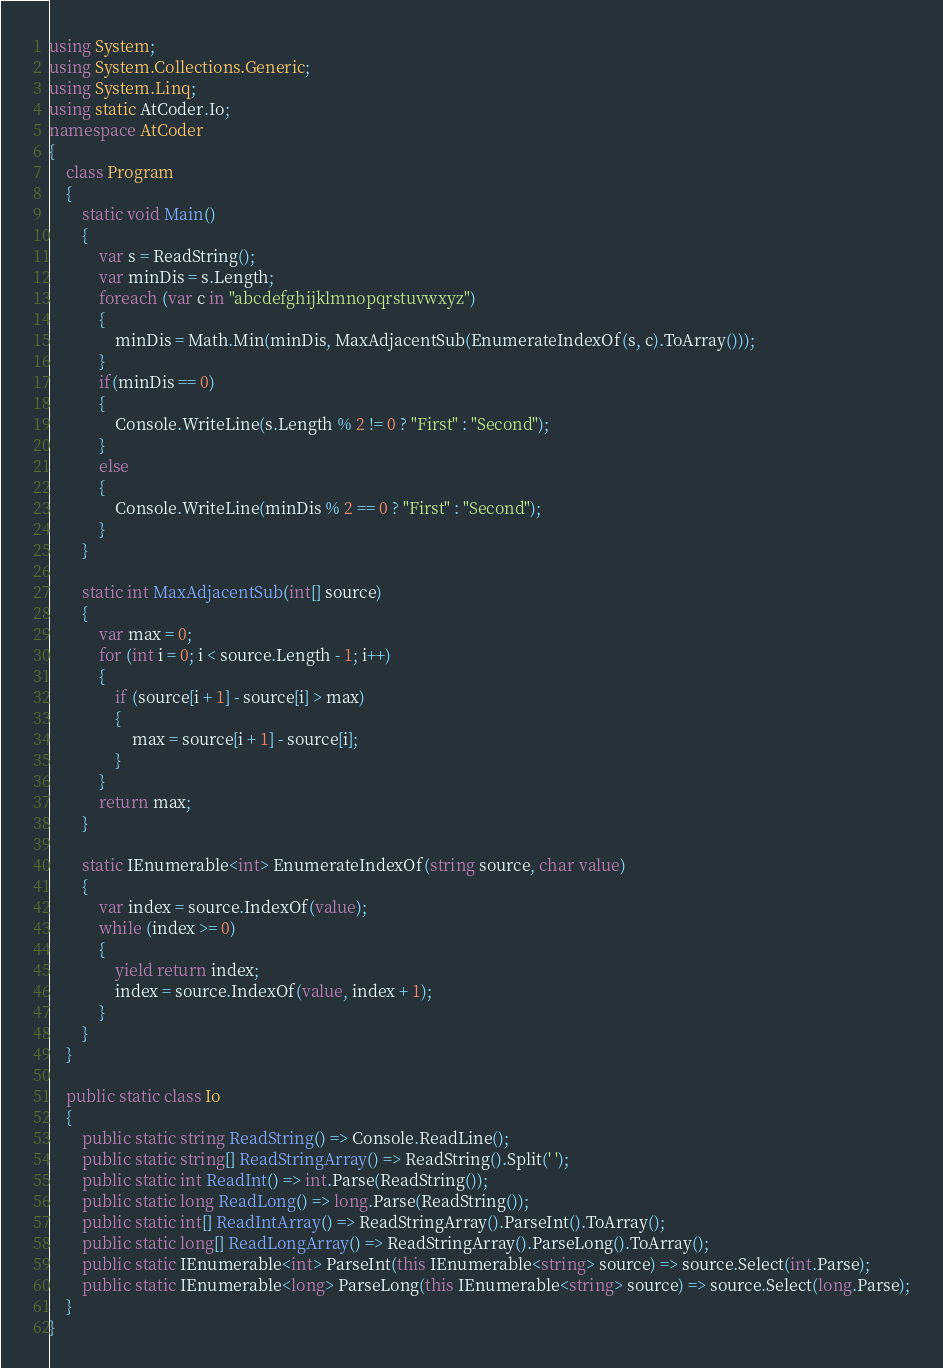<code> <loc_0><loc_0><loc_500><loc_500><_C#_>using System;
using System.Collections.Generic;
using System.Linq;
using static AtCoder.Io;
namespace AtCoder
{
    class Program
    {
        static void Main()
        {
            var s = ReadString();
            var minDis = s.Length;
            foreach (var c in "abcdefghijklmnopqrstuvwxyz")
            {
                minDis = Math.Min(minDis, MaxAdjacentSub(EnumerateIndexOf(s, c).ToArray()));
            }
            if(minDis == 0)
            {
                Console.WriteLine(s.Length % 2 != 0 ? "First" : "Second");
            }
            else
            {
                Console.WriteLine(minDis % 2 == 0 ? "First" : "Second");
            }
        }

        static int MaxAdjacentSub(int[] source)
        {
            var max = 0;
            for (int i = 0; i < source.Length - 1; i++)
            {
                if (source[i + 1] - source[i] > max)
                {
                    max = source[i + 1] - source[i];
                }
            }
            return max;
        }

        static IEnumerable<int> EnumerateIndexOf(string source, char value)
        {
            var index = source.IndexOf(value);
            while (index >= 0)
            {
                yield return index;
                index = source.IndexOf(value, index + 1);
            }
        }
    }

    public static class Io
    {
        public static string ReadString() => Console.ReadLine();
        public static string[] ReadStringArray() => ReadString().Split(' ');
        public static int ReadInt() => int.Parse(ReadString());
        public static long ReadLong() => long.Parse(ReadString());
        public static int[] ReadIntArray() => ReadStringArray().ParseInt().ToArray();
        public static long[] ReadLongArray() => ReadStringArray().ParseLong().ToArray();
        public static IEnumerable<int> ParseInt(this IEnumerable<string> source) => source.Select(int.Parse);
        public static IEnumerable<long> ParseLong(this IEnumerable<string> source) => source.Select(long.Parse);
    }
}
</code> 